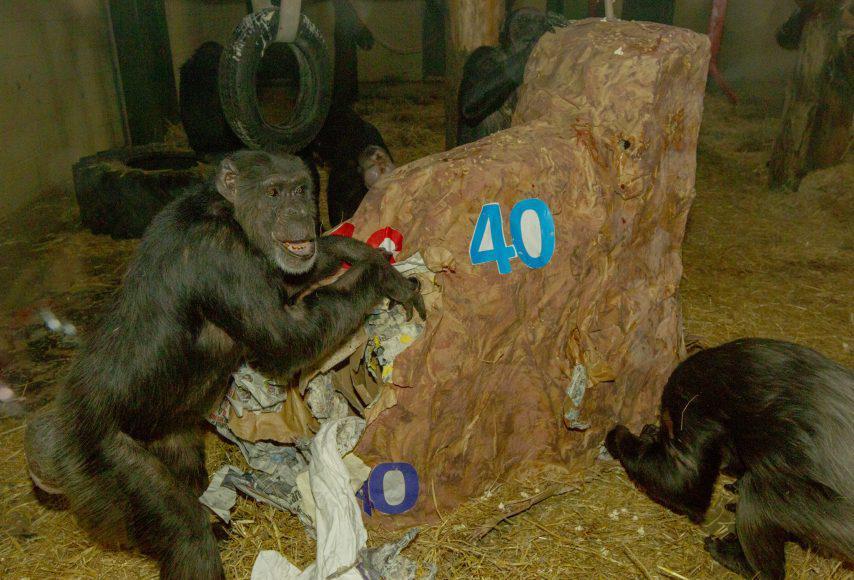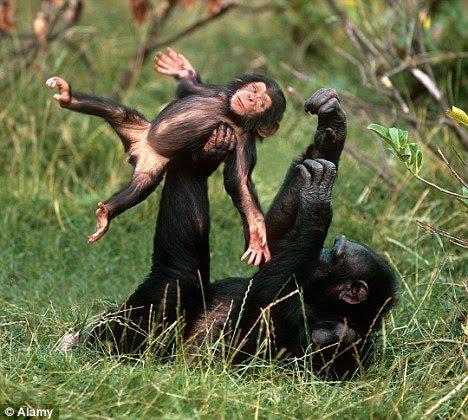The first image is the image on the left, the second image is the image on the right. For the images displayed, is the sentence "There are more primates in the image on the right." factually correct? Answer yes or no. No. The first image is the image on the left, the second image is the image on the right. Evaluate the accuracy of this statement regarding the images: "One image shows a group of chimps outdoors in front of a brown squarish structure, and the other image shows chimps near a tree and manmade structures.". Is it true? Answer yes or no. No. 